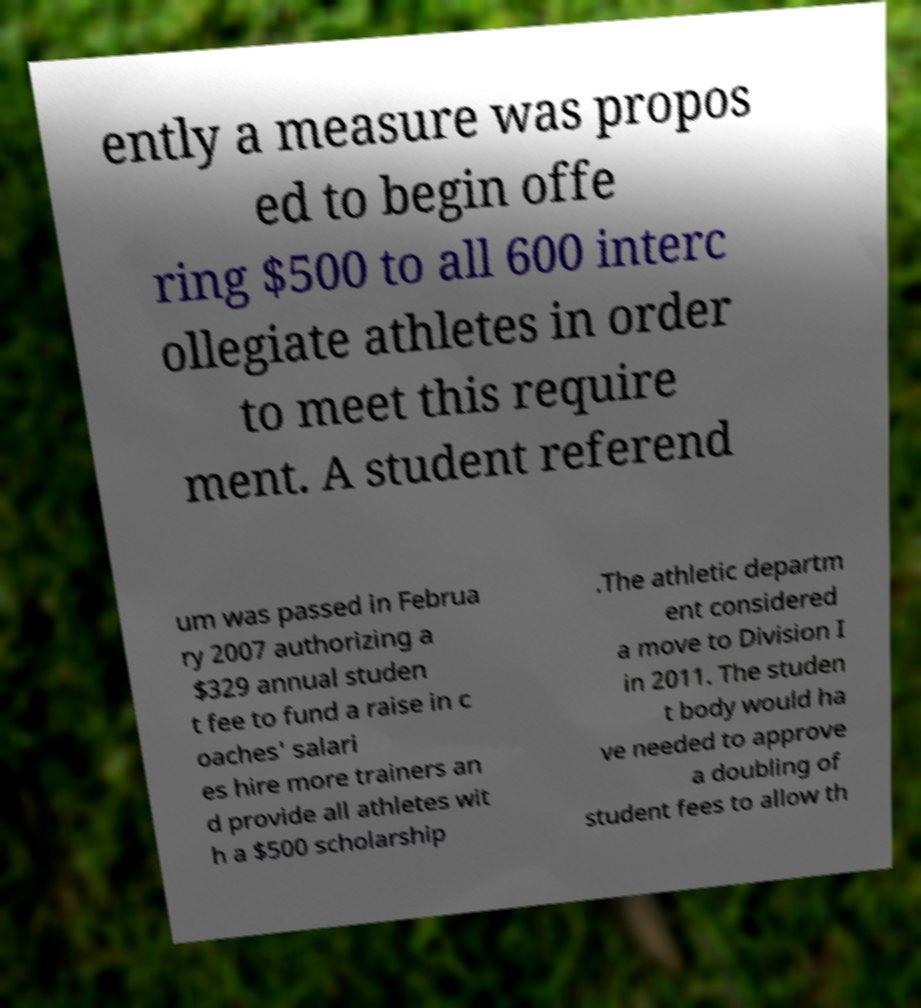For documentation purposes, I need the text within this image transcribed. Could you provide that? ently a measure was propos ed to begin offe ring $500 to all 600 interc ollegiate athletes in order to meet this require ment. A student referend um was passed in Februa ry 2007 authorizing a $329 annual studen t fee to fund a raise in c oaches' salari es hire more trainers an d provide all athletes wit h a $500 scholarship .The athletic departm ent considered a move to Division I in 2011. The studen t body would ha ve needed to approve a doubling of student fees to allow th 